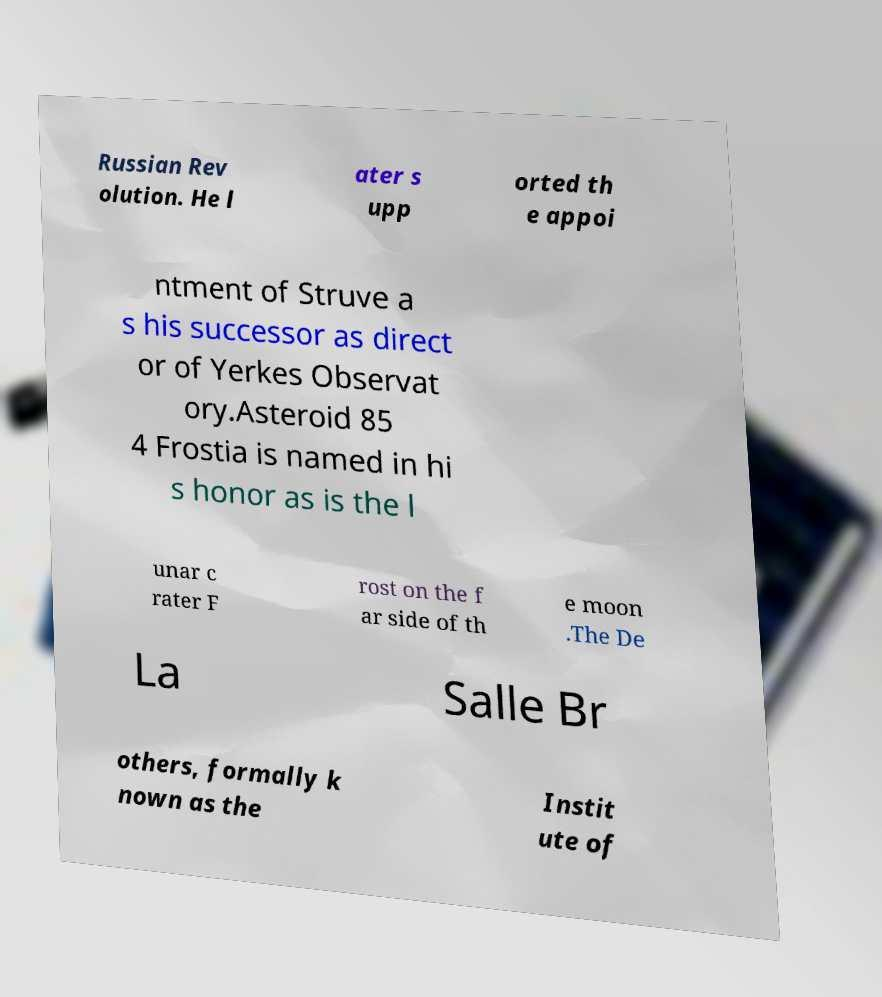Could you assist in decoding the text presented in this image and type it out clearly? Russian Rev olution. He l ater s upp orted th e appoi ntment of Struve a s his successor as direct or of Yerkes Observat ory.Asteroid 85 4 Frostia is named in hi s honor as is the l unar c rater F rost on the f ar side of th e moon .The De La Salle Br others, formally k nown as the Instit ute of 